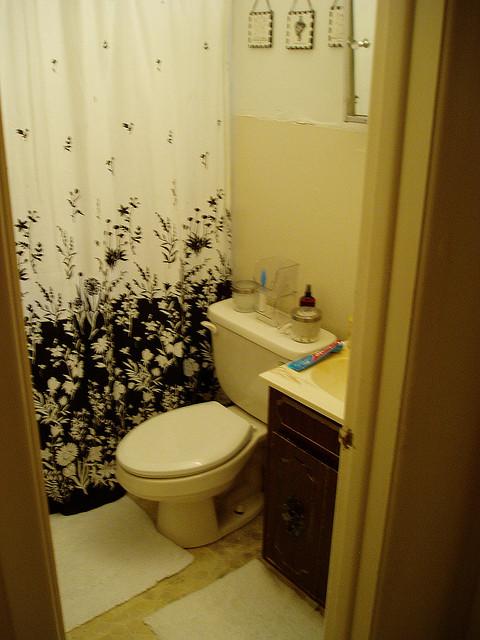Is there toothpaste on the sink?
Keep it brief. Yes. How many rugs are there?
Be succinct. 2. What color is the shower curtain?
Short answer required. Black and white. 